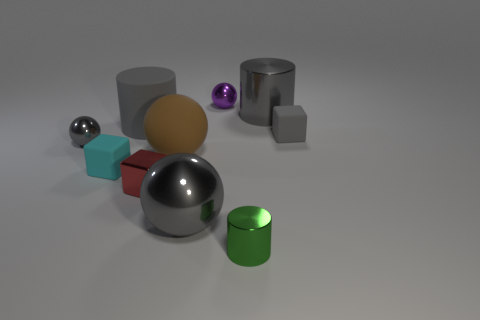Subtract all gray cylinders. How many cylinders are left? 1 Subtract all red balls. How many gray cylinders are left? 2 Subtract all purple balls. How many balls are left? 3 Subtract all balls. How many objects are left? 6 Subtract 0 cyan cylinders. How many objects are left? 10 Subtract 2 cylinders. How many cylinders are left? 1 Subtract all gray cubes. Subtract all brown balls. How many cubes are left? 2 Subtract all gray rubber cubes. Subtract all small cylinders. How many objects are left? 8 Add 7 big brown balls. How many big brown balls are left? 8 Add 10 small green rubber cylinders. How many small green rubber cylinders exist? 10 